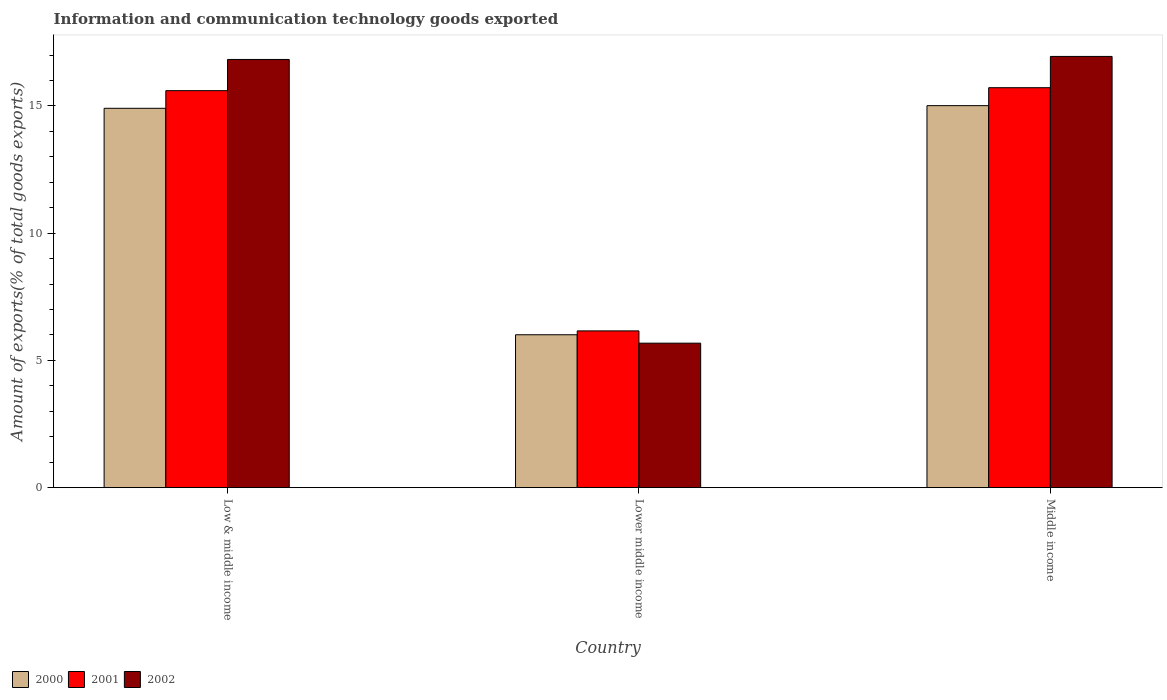How many groups of bars are there?
Offer a very short reply. 3. Are the number of bars per tick equal to the number of legend labels?
Keep it short and to the point. Yes. Are the number of bars on each tick of the X-axis equal?
Your answer should be very brief. Yes. How many bars are there on the 2nd tick from the right?
Ensure brevity in your answer.  3. What is the label of the 3rd group of bars from the left?
Offer a terse response. Middle income. In how many cases, is the number of bars for a given country not equal to the number of legend labels?
Provide a succinct answer. 0. What is the amount of goods exported in 2001 in Lower middle income?
Give a very brief answer. 6.16. Across all countries, what is the maximum amount of goods exported in 2000?
Give a very brief answer. 15.01. Across all countries, what is the minimum amount of goods exported in 2001?
Provide a short and direct response. 6.16. In which country was the amount of goods exported in 2002 maximum?
Your answer should be compact. Middle income. In which country was the amount of goods exported in 2001 minimum?
Your answer should be compact. Lower middle income. What is the total amount of goods exported in 2001 in the graph?
Ensure brevity in your answer.  37.47. What is the difference between the amount of goods exported in 2002 in Low & middle income and that in Lower middle income?
Ensure brevity in your answer.  11.15. What is the difference between the amount of goods exported in 2002 in Lower middle income and the amount of goods exported in 2000 in Middle income?
Provide a succinct answer. -9.33. What is the average amount of goods exported in 2001 per country?
Offer a terse response. 12.49. What is the difference between the amount of goods exported of/in 2000 and amount of goods exported of/in 2002 in Low & middle income?
Offer a terse response. -1.92. What is the ratio of the amount of goods exported in 2002 in Low & middle income to that in Lower middle income?
Offer a terse response. 2.96. Is the amount of goods exported in 2000 in Low & middle income less than that in Lower middle income?
Offer a terse response. No. Is the difference between the amount of goods exported in 2000 in Low & middle income and Middle income greater than the difference between the amount of goods exported in 2002 in Low & middle income and Middle income?
Provide a short and direct response. Yes. What is the difference between the highest and the second highest amount of goods exported in 2001?
Your answer should be very brief. 9.44. What is the difference between the highest and the lowest amount of goods exported in 2001?
Your answer should be very brief. 9.56. Is the sum of the amount of goods exported in 2001 in Low & middle income and Lower middle income greater than the maximum amount of goods exported in 2002 across all countries?
Provide a succinct answer. Yes. What does the 2nd bar from the left in Lower middle income represents?
Offer a terse response. 2001. How many bars are there?
Provide a short and direct response. 9. Does the graph contain any zero values?
Provide a succinct answer. No. Does the graph contain grids?
Provide a succinct answer. No. How are the legend labels stacked?
Provide a short and direct response. Horizontal. What is the title of the graph?
Your answer should be very brief. Information and communication technology goods exported. Does "1980" appear as one of the legend labels in the graph?
Offer a very short reply. No. What is the label or title of the X-axis?
Your answer should be compact. Country. What is the label or title of the Y-axis?
Offer a very short reply. Amount of exports(% of total goods exports). What is the Amount of exports(% of total goods exports) in 2000 in Low & middle income?
Your answer should be compact. 14.91. What is the Amount of exports(% of total goods exports) of 2001 in Low & middle income?
Keep it short and to the point. 15.6. What is the Amount of exports(% of total goods exports) in 2002 in Low & middle income?
Provide a succinct answer. 16.82. What is the Amount of exports(% of total goods exports) in 2000 in Lower middle income?
Your answer should be very brief. 6.01. What is the Amount of exports(% of total goods exports) in 2001 in Lower middle income?
Provide a short and direct response. 6.16. What is the Amount of exports(% of total goods exports) of 2002 in Lower middle income?
Your response must be concise. 5.68. What is the Amount of exports(% of total goods exports) in 2000 in Middle income?
Make the answer very short. 15.01. What is the Amount of exports(% of total goods exports) of 2001 in Middle income?
Ensure brevity in your answer.  15.72. What is the Amount of exports(% of total goods exports) in 2002 in Middle income?
Your answer should be very brief. 16.94. Across all countries, what is the maximum Amount of exports(% of total goods exports) of 2000?
Offer a terse response. 15.01. Across all countries, what is the maximum Amount of exports(% of total goods exports) of 2001?
Offer a very short reply. 15.72. Across all countries, what is the maximum Amount of exports(% of total goods exports) of 2002?
Keep it short and to the point. 16.94. Across all countries, what is the minimum Amount of exports(% of total goods exports) in 2000?
Make the answer very short. 6.01. Across all countries, what is the minimum Amount of exports(% of total goods exports) of 2001?
Your answer should be very brief. 6.16. Across all countries, what is the minimum Amount of exports(% of total goods exports) of 2002?
Your answer should be very brief. 5.68. What is the total Amount of exports(% of total goods exports) of 2000 in the graph?
Offer a terse response. 35.92. What is the total Amount of exports(% of total goods exports) of 2001 in the graph?
Give a very brief answer. 37.47. What is the total Amount of exports(% of total goods exports) of 2002 in the graph?
Provide a short and direct response. 39.45. What is the difference between the Amount of exports(% of total goods exports) in 2000 in Low & middle income and that in Lower middle income?
Keep it short and to the point. 8.9. What is the difference between the Amount of exports(% of total goods exports) in 2001 in Low & middle income and that in Lower middle income?
Offer a terse response. 9.44. What is the difference between the Amount of exports(% of total goods exports) in 2002 in Low & middle income and that in Lower middle income?
Provide a short and direct response. 11.15. What is the difference between the Amount of exports(% of total goods exports) in 2000 in Low & middle income and that in Middle income?
Your response must be concise. -0.1. What is the difference between the Amount of exports(% of total goods exports) of 2001 in Low & middle income and that in Middle income?
Provide a short and direct response. -0.12. What is the difference between the Amount of exports(% of total goods exports) in 2002 in Low & middle income and that in Middle income?
Provide a short and direct response. -0.12. What is the difference between the Amount of exports(% of total goods exports) of 2000 in Lower middle income and that in Middle income?
Ensure brevity in your answer.  -9. What is the difference between the Amount of exports(% of total goods exports) of 2001 in Lower middle income and that in Middle income?
Make the answer very short. -9.56. What is the difference between the Amount of exports(% of total goods exports) of 2002 in Lower middle income and that in Middle income?
Provide a short and direct response. -11.27. What is the difference between the Amount of exports(% of total goods exports) in 2000 in Low & middle income and the Amount of exports(% of total goods exports) in 2001 in Lower middle income?
Make the answer very short. 8.75. What is the difference between the Amount of exports(% of total goods exports) of 2000 in Low & middle income and the Amount of exports(% of total goods exports) of 2002 in Lower middle income?
Give a very brief answer. 9.23. What is the difference between the Amount of exports(% of total goods exports) in 2001 in Low & middle income and the Amount of exports(% of total goods exports) in 2002 in Lower middle income?
Provide a short and direct response. 9.92. What is the difference between the Amount of exports(% of total goods exports) of 2000 in Low & middle income and the Amount of exports(% of total goods exports) of 2001 in Middle income?
Provide a succinct answer. -0.81. What is the difference between the Amount of exports(% of total goods exports) in 2000 in Low & middle income and the Amount of exports(% of total goods exports) in 2002 in Middle income?
Provide a succinct answer. -2.04. What is the difference between the Amount of exports(% of total goods exports) of 2001 in Low & middle income and the Amount of exports(% of total goods exports) of 2002 in Middle income?
Your answer should be very brief. -1.34. What is the difference between the Amount of exports(% of total goods exports) in 2000 in Lower middle income and the Amount of exports(% of total goods exports) in 2001 in Middle income?
Your response must be concise. -9.71. What is the difference between the Amount of exports(% of total goods exports) in 2000 in Lower middle income and the Amount of exports(% of total goods exports) in 2002 in Middle income?
Your answer should be very brief. -10.94. What is the difference between the Amount of exports(% of total goods exports) in 2001 in Lower middle income and the Amount of exports(% of total goods exports) in 2002 in Middle income?
Your answer should be very brief. -10.78. What is the average Amount of exports(% of total goods exports) of 2000 per country?
Give a very brief answer. 11.97. What is the average Amount of exports(% of total goods exports) of 2001 per country?
Provide a succinct answer. 12.49. What is the average Amount of exports(% of total goods exports) of 2002 per country?
Ensure brevity in your answer.  13.15. What is the difference between the Amount of exports(% of total goods exports) of 2000 and Amount of exports(% of total goods exports) of 2001 in Low & middle income?
Provide a succinct answer. -0.69. What is the difference between the Amount of exports(% of total goods exports) in 2000 and Amount of exports(% of total goods exports) in 2002 in Low & middle income?
Your answer should be very brief. -1.92. What is the difference between the Amount of exports(% of total goods exports) of 2001 and Amount of exports(% of total goods exports) of 2002 in Low & middle income?
Offer a very short reply. -1.23. What is the difference between the Amount of exports(% of total goods exports) of 2000 and Amount of exports(% of total goods exports) of 2001 in Lower middle income?
Provide a succinct answer. -0.15. What is the difference between the Amount of exports(% of total goods exports) in 2000 and Amount of exports(% of total goods exports) in 2002 in Lower middle income?
Your response must be concise. 0.33. What is the difference between the Amount of exports(% of total goods exports) of 2001 and Amount of exports(% of total goods exports) of 2002 in Lower middle income?
Your response must be concise. 0.48. What is the difference between the Amount of exports(% of total goods exports) in 2000 and Amount of exports(% of total goods exports) in 2001 in Middle income?
Keep it short and to the point. -0.71. What is the difference between the Amount of exports(% of total goods exports) of 2000 and Amount of exports(% of total goods exports) of 2002 in Middle income?
Give a very brief answer. -1.93. What is the difference between the Amount of exports(% of total goods exports) of 2001 and Amount of exports(% of total goods exports) of 2002 in Middle income?
Offer a very short reply. -1.23. What is the ratio of the Amount of exports(% of total goods exports) of 2000 in Low & middle income to that in Lower middle income?
Provide a succinct answer. 2.48. What is the ratio of the Amount of exports(% of total goods exports) in 2001 in Low & middle income to that in Lower middle income?
Provide a short and direct response. 2.53. What is the ratio of the Amount of exports(% of total goods exports) in 2002 in Low & middle income to that in Lower middle income?
Provide a short and direct response. 2.96. What is the ratio of the Amount of exports(% of total goods exports) of 2002 in Low & middle income to that in Middle income?
Provide a succinct answer. 0.99. What is the ratio of the Amount of exports(% of total goods exports) in 2000 in Lower middle income to that in Middle income?
Your answer should be compact. 0.4. What is the ratio of the Amount of exports(% of total goods exports) in 2001 in Lower middle income to that in Middle income?
Make the answer very short. 0.39. What is the ratio of the Amount of exports(% of total goods exports) in 2002 in Lower middle income to that in Middle income?
Offer a terse response. 0.34. What is the difference between the highest and the second highest Amount of exports(% of total goods exports) in 2000?
Provide a succinct answer. 0.1. What is the difference between the highest and the second highest Amount of exports(% of total goods exports) of 2001?
Offer a terse response. 0.12. What is the difference between the highest and the second highest Amount of exports(% of total goods exports) of 2002?
Your answer should be compact. 0.12. What is the difference between the highest and the lowest Amount of exports(% of total goods exports) of 2000?
Offer a terse response. 9. What is the difference between the highest and the lowest Amount of exports(% of total goods exports) in 2001?
Your answer should be very brief. 9.56. What is the difference between the highest and the lowest Amount of exports(% of total goods exports) of 2002?
Give a very brief answer. 11.27. 